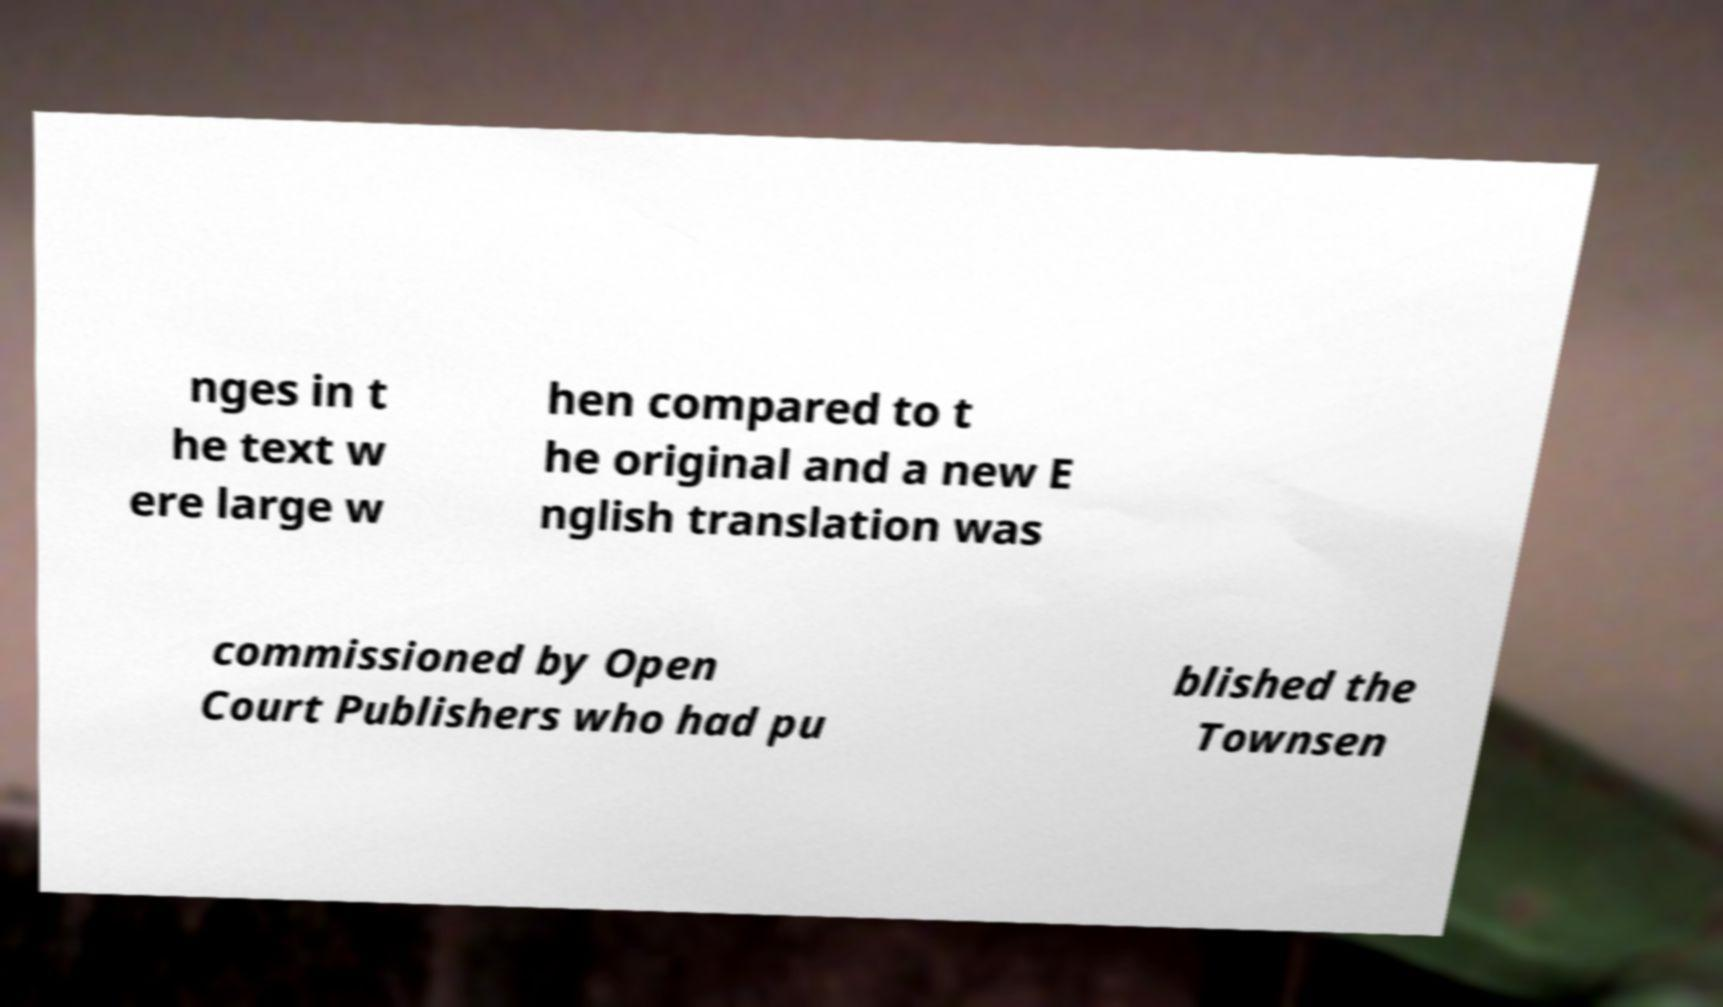What messages or text are displayed in this image? I need them in a readable, typed format. nges in t he text w ere large w hen compared to t he original and a new E nglish translation was commissioned by Open Court Publishers who had pu blished the Townsen 